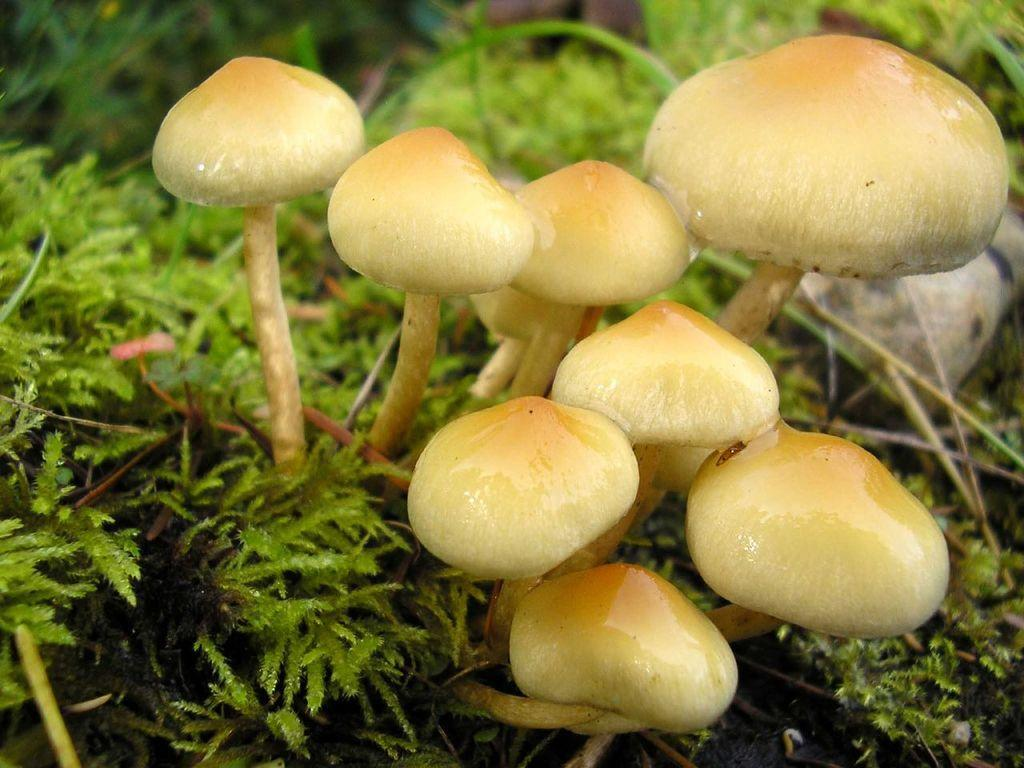What type of fungi can be seen in the image? There are mushrooms in the image. What color are the mushrooms? The mushrooms are in cream color. What other type of vegetation is present in the image? There are plants in the image. What color are the plants? The plants are in green color. Where is the cable located in the image? There is no cable present in the image. What role does the mother play in the image? There is no reference to a mother or any human presence in the image. 